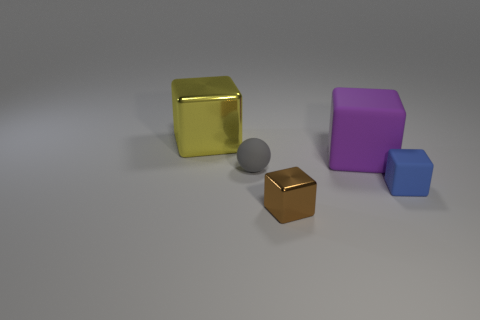How many purple matte blocks are behind the small brown shiny thing?
Your answer should be compact. 1. There is a big shiny thing that is behind the blue matte thing; does it have the same shape as the large object right of the small brown metal object?
Your answer should be compact. Yes. How many other things are there of the same color as the sphere?
Give a very brief answer. 0. What is the material of the big yellow cube that is behind the large purple rubber thing to the right of the large object left of the tiny gray matte thing?
Your response must be concise. Metal. The big thing right of the large object on the left side of the purple rubber thing is made of what material?
Your answer should be very brief. Rubber. Is the number of tiny blocks behind the small brown metallic cube less than the number of big green metallic things?
Your response must be concise. No. What is the shape of the object to the left of the small sphere?
Give a very brief answer. Cube. There is a gray thing; is it the same size as the shiny block that is in front of the big metal block?
Make the answer very short. Yes. Is there a tiny green block that has the same material as the blue thing?
Offer a terse response. No. How many spheres are rubber things or tiny matte things?
Give a very brief answer. 1. 